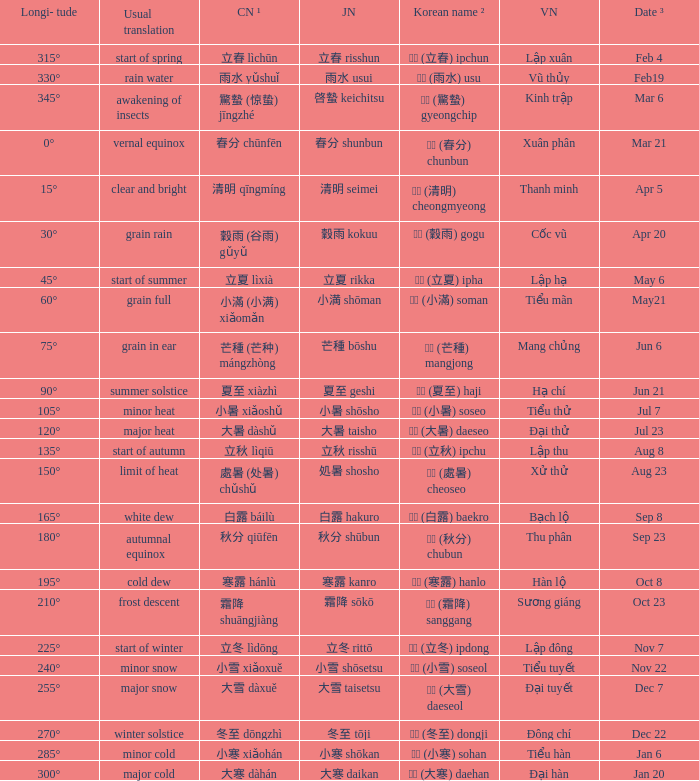Parse the full table. {'header': ['Longi- tude', 'Usual translation', 'CN ¹', 'JN', 'Korean name ²', 'VN', 'Date ³'], 'rows': [['315°', 'start of spring', '立春 lìchūn', '立春 risshun', '입춘 (立春) ipchun', 'Lập xuân', 'Feb 4'], ['330°', 'rain water', '雨水 yǔshuǐ', '雨水 usui', '우수 (雨水) usu', 'Vũ thủy', 'Feb19'], ['345°', 'awakening of insects', '驚蟄 (惊蛰) jīngzhé', '啓蟄 keichitsu', '경칩 (驚蟄) gyeongchip', 'Kinh trập', 'Mar 6'], ['0°', 'vernal equinox', '春分 chūnfēn', '春分 shunbun', '춘분 (春分) chunbun', 'Xuân phân', 'Mar 21'], ['15°', 'clear and bright', '清明 qīngmíng', '清明 seimei', '청명 (清明) cheongmyeong', 'Thanh minh', 'Apr 5'], ['30°', 'grain rain', '穀雨 (谷雨) gǔyǔ', '穀雨 kokuu', '곡우 (穀雨) gogu', 'Cốc vũ', 'Apr 20'], ['45°', 'start of summer', '立夏 lìxià', '立夏 rikka', '입하 (立夏) ipha', 'Lập hạ', 'May 6'], ['60°', 'grain full', '小滿 (小满) xiǎomǎn', '小満 shōman', '소만 (小滿) soman', 'Tiểu mãn', 'May21'], ['75°', 'grain in ear', '芒種 (芒种) mángzhòng', '芒種 bōshu', '망종 (芒種) mangjong', 'Mang chủng', 'Jun 6'], ['90°', 'summer solstice', '夏至 xiàzhì', '夏至 geshi', '하지 (夏至) haji', 'Hạ chí', 'Jun 21'], ['105°', 'minor heat', '小暑 xiǎoshǔ', '小暑 shōsho', '소서 (小暑) soseo', 'Tiểu thử', 'Jul 7'], ['120°', 'major heat', '大暑 dàshǔ', '大暑 taisho', '대서 (大暑) daeseo', 'Đại thử', 'Jul 23'], ['135°', 'start of autumn', '立秋 lìqiū', '立秋 risshū', '입추 (立秋) ipchu', 'Lập thu', 'Aug 8'], ['150°', 'limit of heat', '處暑 (处暑) chǔshǔ', '処暑 shosho', '처서 (處暑) cheoseo', 'Xử thử', 'Aug 23'], ['165°', 'white dew', '白露 báilù', '白露 hakuro', '백로 (白露) baekro', 'Bạch lộ', 'Sep 8'], ['180°', 'autumnal equinox', '秋分 qiūfēn', '秋分 shūbun', '추분 (秋分) chubun', 'Thu phân', 'Sep 23'], ['195°', 'cold dew', '寒露 hánlù', '寒露 kanro', '한로 (寒露) hanlo', 'Hàn lộ', 'Oct 8'], ['210°', 'frost descent', '霜降 shuāngjiàng', '霜降 sōkō', '상강 (霜降) sanggang', 'Sương giáng', 'Oct 23'], ['225°', 'start of winter', '立冬 lìdōng', '立冬 rittō', '입동 (立冬) ipdong', 'Lập đông', 'Nov 7'], ['240°', 'minor snow', '小雪 xiǎoxuě', '小雪 shōsetsu', '소설 (小雪) soseol', 'Tiểu tuyết', 'Nov 22'], ['255°', 'major snow', '大雪 dàxuě', '大雪 taisetsu', '대설 (大雪) daeseol', 'Đại tuyết', 'Dec 7'], ['270°', 'winter solstice', '冬至 dōngzhì', '冬至 tōji', '동지 (冬至) dongji', 'Đông chí', 'Dec 22'], ['285°', 'minor cold', '小寒 xiǎohán', '小寒 shōkan', '소한 (小寒) sohan', 'Tiểu hàn', 'Jan 6'], ['300°', 'major cold', '大寒 dàhán', '大寒 daikan', '대한 (大寒) daehan', 'Đại hàn', 'Jan 20']]} Which Longi- tude is on jun 6? 75°. 